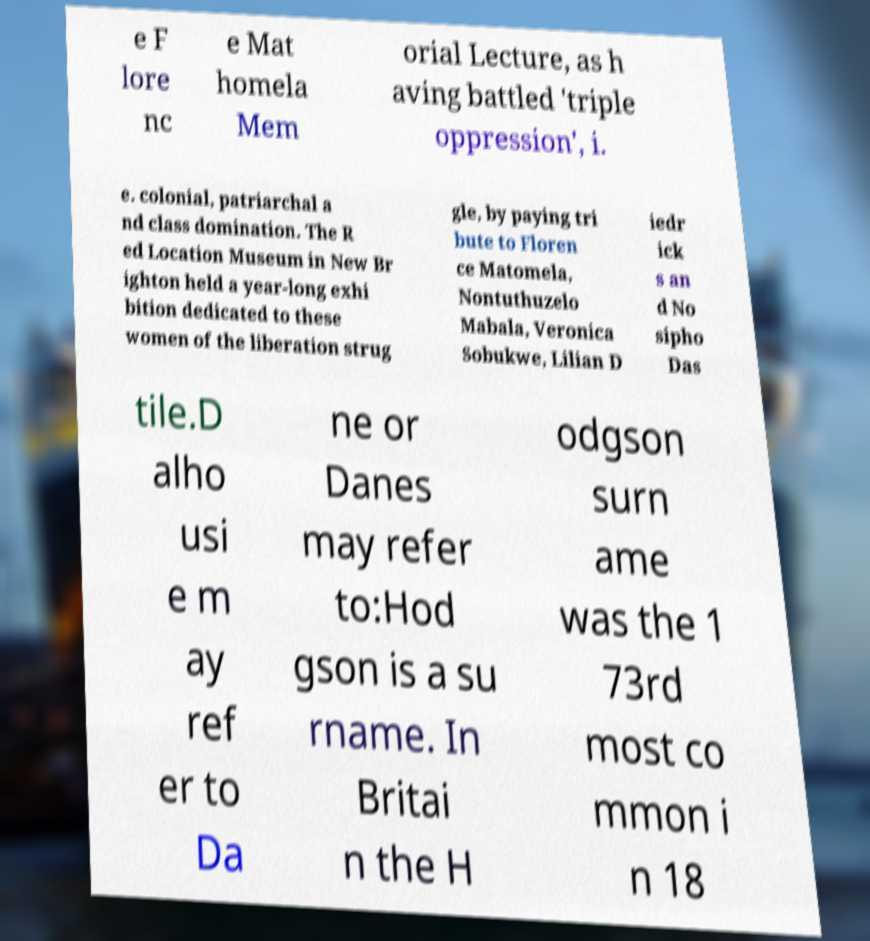Please read and relay the text visible in this image. What does it say? e F lore nc e Mat homela Mem orial Lecture, as h aving battled 'triple oppression', i. e. colonial, patriarchal a nd class domination. The R ed Location Museum in New Br ighton held a year-long exhi bition dedicated to these women of the liberation strug gle, by paying tri bute to Floren ce Matomela, Nontuthuzelo Mabala, Veronica Sobukwe, Lilian D iedr ick s an d No sipho Das tile.D alho usi e m ay ref er to Da ne or Danes may refer to:Hod gson is a su rname. In Britai n the H odgson surn ame was the 1 73rd most co mmon i n 18 